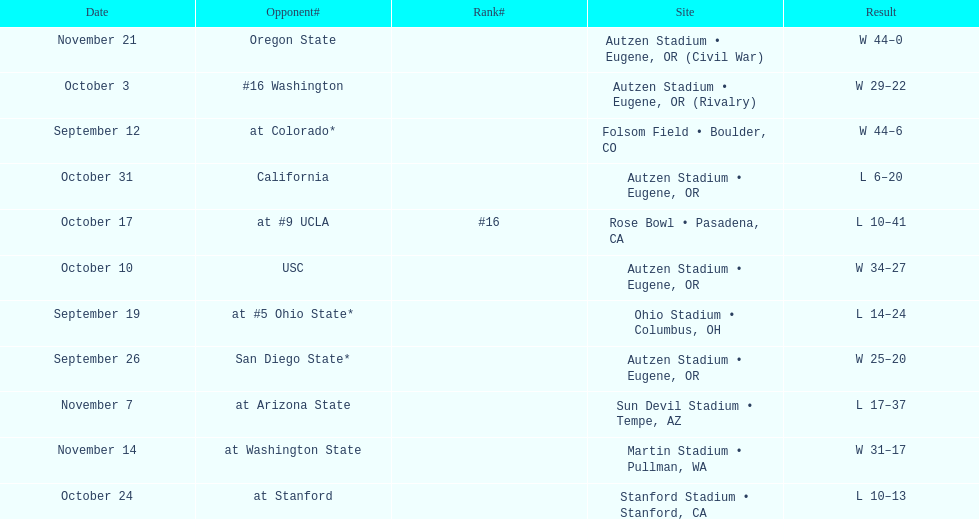Parse the full table. {'header': ['Date', 'Opponent#', 'Rank#', 'Site', 'Result'], 'rows': [['November 21', 'Oregon State', '', 'Autzen Stadium • Eugene, OR (Civil War)', 'W\xa044–0'], ['October 3', '#16\xa0Washington', '', 'Autzen Stadium • Eugene, OR (Rivalry)', 'W\xa029–22'], ['September 12', 'at\xa0Colorado*', '', 'Folsom Field • Boulder, CO', 'W\xa044–6'], ['October 31', 'California', '', 'Autzen Stadium • Eugene, OR', 'L\xa06–20'], ['October 17', 'at\xa0#9\xa0UCLA', '#16', 'Rose Bowl • Pasadena, CA', 'L\xa010–41'], ['October 10', 'USC', '', 'Autzen Stadium • Eugene, OR', 'W\xa034–27'], ['September 19', 'at\xa0#5\xa0Ohio State*', '', 'Ohio Stadium • Columbus, OH', 'L\xa014–24'], ['September 26', 'San Diego State*', '', 'Autzen Stadium • Eugene, OR', 'W\xa025–20'], ['November 7', 'at\xa0Arizona State', '', 'Sun Devil Stadium • Tempe, AZ', 'L\xa017–37'], ['November 14', 'at\xa0Washington State', '', 'Martin Stadium • Pullman, WA', 'W\xa031–17'], ['October 24', 'at\xa0Stanford', '', 'Stanford Stadium • Stanford, CA', 'L\xa010–13']]} Who was their last opponent of the season? Oregon State. 